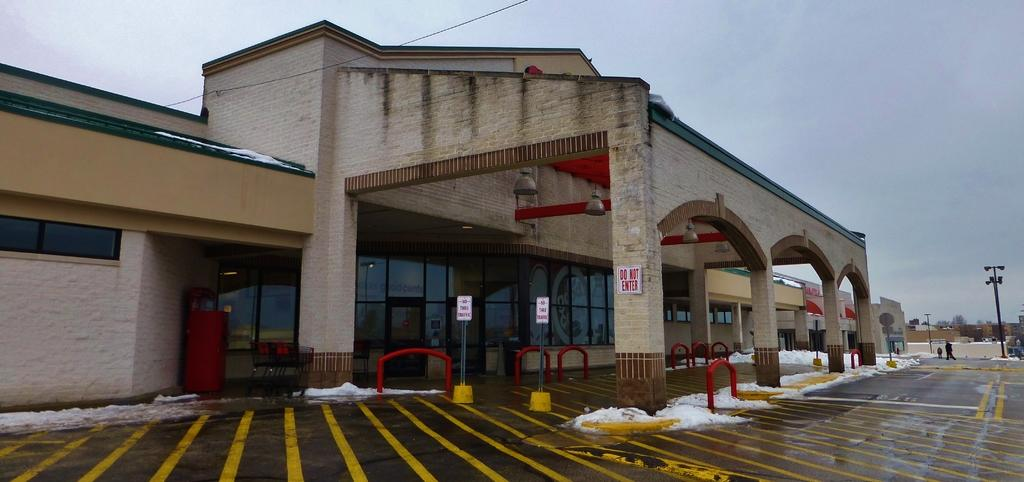<image>
Render a clear and concise summary of the photo. A outside of a building with a Do not enter sign on it. 